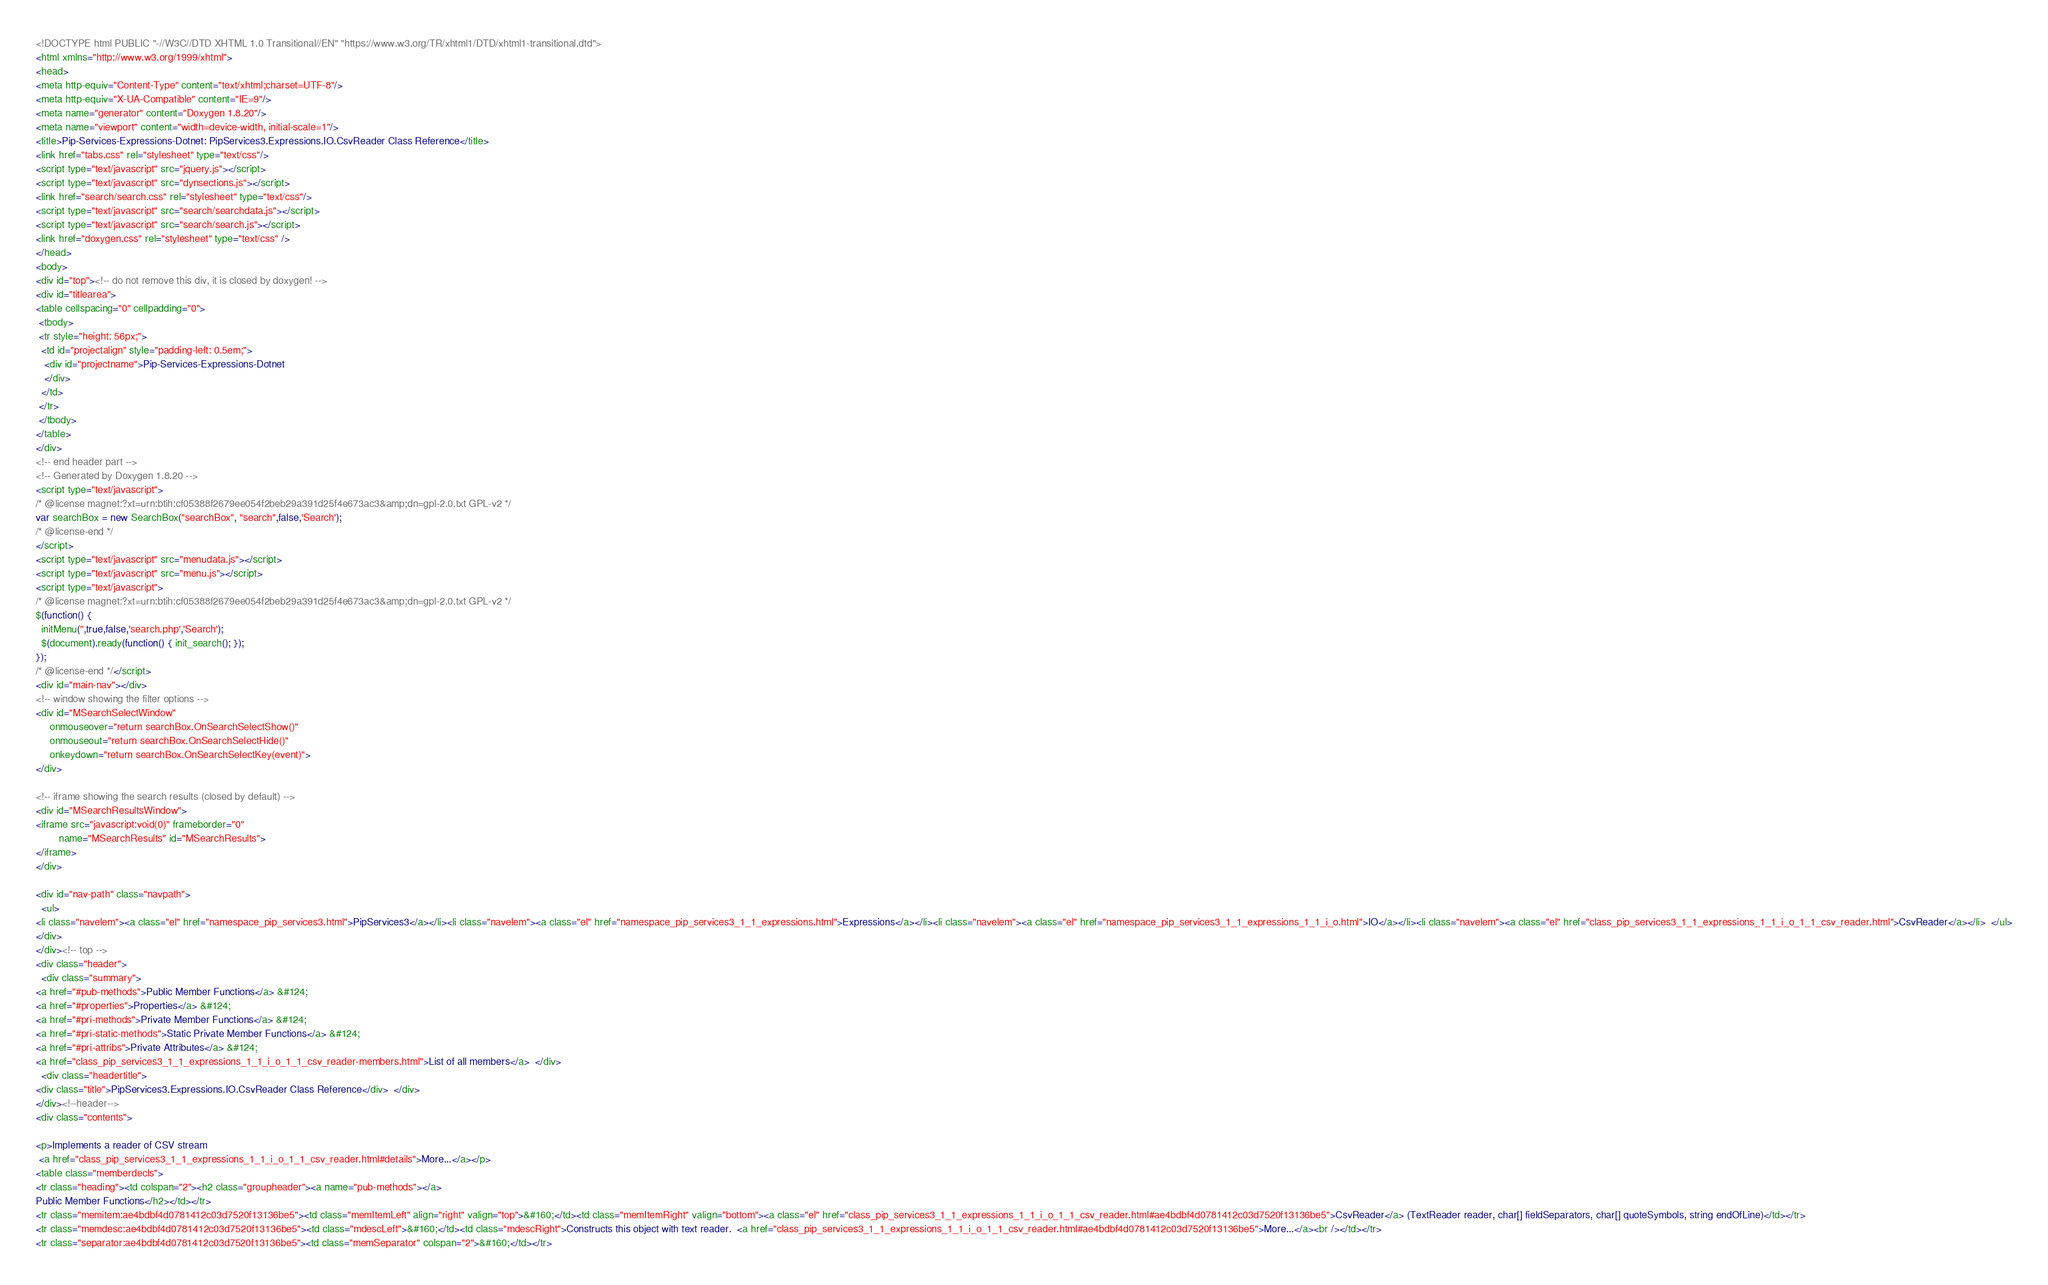Convert code to text. <code><loc_0><loc_0><loc_500><loc_500><_HTML_><!DOCTYPE html PUBLIC "-//W3C//DTD XHTML 1.0 Transitional//EN" "https://www.w3.org/TR/xhtml1/DTD/xhtml1-transitional.dtd">
<html xmlns="http://www.w3.org/1999/xhtml">
<head>
<meta http-equiv="Content-Type" content="text/xhtml;charset=UTF-8"/>
<meta http-equiv="X-UA-Compatible" content="IE=9"/>
<meta name="generator" content="Doxygen 1.8.20"/>
<meta name="viewport" content="width=device-width, initial-scale=1"/>
<title>Pip-Services-Expressions-Dotnet: PipServices3.Expressions.IO.CsvReader Class Reference</title>
<link href="tabs.css" rel="stylesheet" type="text/css"/>
<script type="text/javascript" src="jquery.js"></script>
<script type="text/javascript" src="dynsections.js"></script>
<link href="search/search.css" rel="stylesheet" type="text/css"/>
<script type="text/javascript" src="search/searchdata.js"></script>
<script type="text/javascript" src="search/search.js"></script>
<link href="doxygen.css" rel="stylesheet" type="text/css" />
</head>
<body>
<div id="top"><!-- do not remove this div, it is closed by doxygen! -->
<div id="titlearea">
<table cellspacing="0" cellpadding="0">
 <tbody>
 <tr style="height: 56px;">
  <td id="projectalign" style="padding-left: 0.5em;">
   <div id="projectname">Pip-Services-Expressions-Dotnet
   </div>
  </td>
 </tr>
 </tbody>
</table>
</div>
<!-- end header part -->
<!-- Generated by Doxygen 1.8.20 -->
<script type="text/javascript">
/* @license magnet:?xt=urn:btih:cf05388f2679ee054f2beb29a391d25f4e673ac3&amp;dn=gpl-2.0.txt GPL-v2 */
var searchBox = new SearchBox("searchBox", "search",false,'Search');
/* @license-end */
</script>
<script type="text/javascript" src="menudata.js"></script>
<script type="text/javascript" src="menu.js"></script>
<script type="text/javascript">
/* @license magnet:?xt=urn:btih:cf05388f2679ee054f2beb29a391d25f4e673ac3&amp;dn=gpl-2.0.txt GPL-v2 */
$(function() {
  initMenu('',true,false,'search.php','Search');
  $(document).ready(function() { init_search(); });
});
/* @license-end */</script>
<div id="main-nav"></div>
<!-- window showing the filter options -->
<div id="MSearchSelectWindow"
     onmouseover="return searchBox.OnSearchSelectShow()"
     onmouseout="return searchBox.OnSearchSelectHide()"
     onkeydown="return searchBox.OnSearchSelectKey(event)">
</div>

<!-- iframe showing the search results (closed by default) -->
<div id="MSearchResultsWindow">
<iframe src="javascript:void(0)" frameborder="0" 
        name="MSearchResults" id="MSearchResults">
</iframe>
</div>

<div id="nav-path" class="navpath">
  <ul>
<li class="navelem"><a class="el" href="namespace_pip_services3.html">PipServices3</a></li><li class="navelem"><a class="el" href="namespace_pip_services3_1_1_expressions.html">Expressions</a></li><li class="navelem"><a class="el" href="namespace_pip_services3_1_1_expressions_1_1_i_o.html">IO</a></li><li class="navelem"><a class="el" href="class_pip_services3_1_1_expressions_1_1_i_o_1_1_csv_reader.html">CsvReader</a></li>  </ul>
</div>
</div><!-- top -->
<div class="header">
  <div class="summary">
<a href="#pub-methods">Public Member Functions</a> &#124;
<a href="#properties">Properties</a> &#124;
<a href="#pri-methods">Private Member Functions</a> &#124;
<a href="#pri-static-methods">Static Private Member Functions</a> &#124;
<a href="#pri-attribs">Private Attributes</a> &#124;
<a href="class_pip_services3_1_1_expressions_1_1_i_o_1_1_csv_reader-members.html">List of all members</a>  </div>
  <div class="headertitle">
<div class="title">PipServices3.Expressions.IO.CsvReader Class Reference</div>  </div>
</div><!--header-->
<div class="contents">

<p>Implements a reader of CSV stream  
 <a href="class_pip_services3_1_1_expressions_1_1_i_o_1_1_csv_reader.html#details">More...</a></p>
<table class="memberdecls">
<tr class="heading"><td colspan="2"><h2 class="groupheader"><a name="pub-methods"></a>
Public Member Functions</h2></td></tr>
<tr class="memitem:ae4bdbf4d0781412c03d7520f13136be5"><td class="memItemLeft" align="right" valign="top">&#160;</td><td class="memItemRight" valign="bottom"><a class="el" href="class_pip_services3_1_1_expressions_1_1_i_o_1_1_csv_reader.html#ae4bdbf4d0781412c03d7520f13136be5">CsvReader</a> (TextReader reader, char[] fieldSeparators, char[] quoteSymbols, string endOfLine)</td></tr>
<tr class="memdesc:ae4bdbf4d0781412c03d7520f13136be5"><td class="mdescLeft">&#160;</td><td class="mdescRight">Constructs this object with text reader.  <a href="class_pip_services3_1_1_expressions_1_1_i_o_1_1_csv_reader.html#ae4bdbf4d0781412c03d7520f13136be5">More...</a><br /></td></tr>
<tr class="separator:ae4bdbf4d0781412c03d7520f13136be5"><td class="memSeparator" colspan="2">&#160;</td></tr></code> 